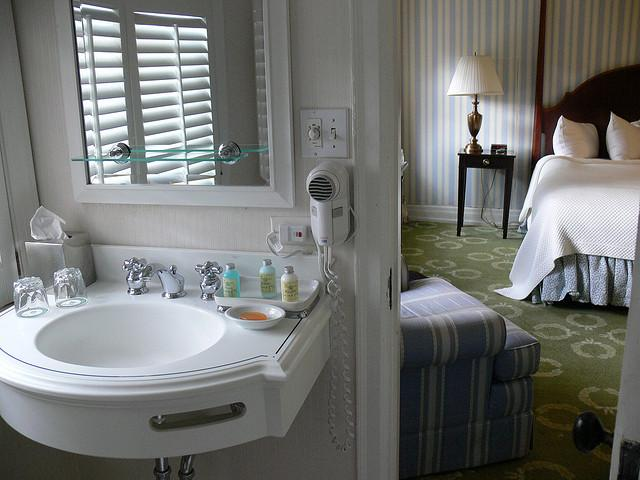What is on the bed? pillows 